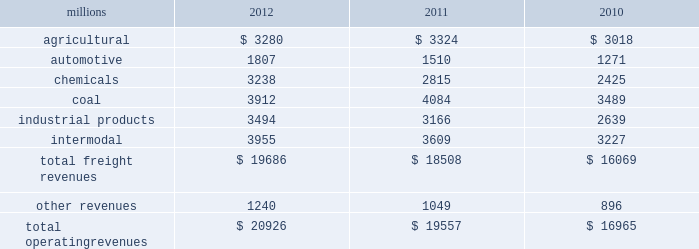Notes to the consolidated financial statements union pacific corporation and subsidiary companies for purposes of this report , unless the context otherwise requires , all references herein to the 201ccorporation 201d , 201cupc 201d , 201cwe 201d , 201cus 201d , and 201cour 201d mean union pacific corporation and its subsidiaries , including union pacific railroad company , which will be separately referred to herein as 201cuprr 201d or the 201crailroad 201d .
Nature of operations operations and segmentation 2013 we are a class i railroad operating in the u.s .
Our network includes 31868 route miles , linking pacific coast and gulf coast ports with the midwest and eastern u.s .
Gateways and providing several corridors to key mexican gateways .
We own 26020 miles and operate on the remainder pursuant to trackage rights or leases .
We serve the western two-thirds of the country and maintain coordinated schedules with other rail carriers for the handling of freight to and from the atlantic coast , the pacific coast , the southeast , the southwest , canada , and mexico .
Export and import traffic is moved through gulf coast and pacific coast ports and across the mexican and canadian borders .
The railroad , along with its subsidiaries and rail affiliates , is our one reportable operating segment .
Although we provide and review revenue by commodity group , we analyze the net financial results of the railroad as one segment due to the integrated nature of our rail network .
The table provides freight revenue by commodity group : millions 2012 2011 2010 .
Although our revenues are principally derived from customers domiciled in the u.s. , the ultimate points of origination or destination for some products transported by us are outside the u.s .
Each of our commodity groups includes revenue from shipments to and from mexico .
Included in the above table are revenues from our mexico business which amounted to $ 1.9 billion in 2012 , $ 1.8 billion in 2011 , and $ 1.6 billion in 2010 .
Basis of presentation 2013 the consolidated financial statements are presented in accordance with accounting principles generally accepted in the u.s .
( gaap ) as codified in the financial accounting standards board ( fasb ) accounting standards codification ( asc ) .
Significant accounting policies principles of consolidation 2013 the consolidated financial statements include the accounts of union pacific corporation and all of its subsidiaries .
Investments in affiliated companies ( 20% ( 20 % ) to 50% ( 50 % ) owned ) are accounted for using the equity method of accounting .
All intercompany transactions are eliminated .
We currently have no less than majority-owned investments that require consolidation under variable interest entity requirements .
Cash and cash equivalents 2013 cash equivalents consist of investments with original maturities of three months or less .
Accounts receivable 2013 accounts receivable includes receivables reduced by an allowance for doubtful accounts .
The allowance is based upon historical losses , credit worthiness of customers , and current economic conditions .
Receivables not expected to be collected in one year and the associated allowances are classified as other assets in our consolidated statements of financial position. .
Did freight revenue in the agricultural group increase at a faster pace in 2012 than in the automotive business? 
Computations: ((3280 / 3324) > (1807 / 1510))
Answer: no. 